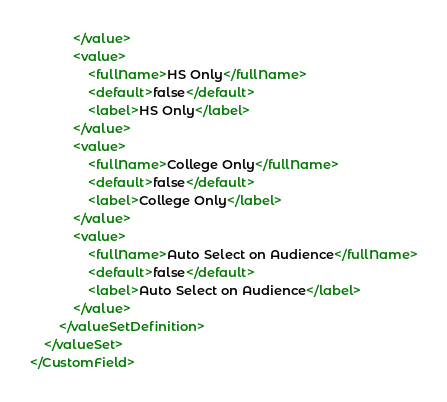Convert code to text. <code><loc_0><loc_0><loc_500><loc_500><_XML_>            </value>
            <value>
                <fullName>HS Only</fullName>
                <default>false</default>
                <label>HS Only</label>
            </value>
            <value>
                <fullName>College Only</fullName>
                <default>false</default>
                <label>College Only</label>
            </value>
            <value>
                <fullName>Auto Select on Audience</fullName>
                <default>false</default>
                <label>Auto Select on Audience</label>
            </value>
        </valueSetDefinition>
    </valueSet>
</CustomField>
</code> 